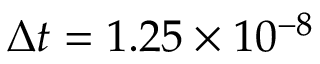Convert formula to latex. <formula><loc_0><loc_0><loc_500><loc_500>\Delta t = 1 . 2 5 \times 1 0 ^ { - 8 }</formula> 